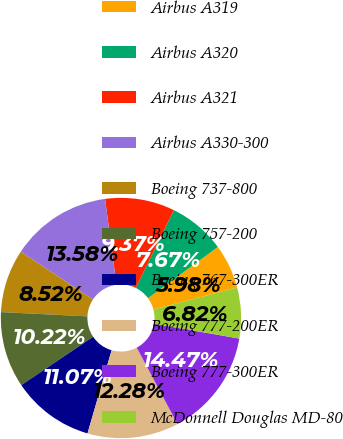<chart> <loc_0><loc_0><loc_500><loc_500><pie_chart><fcel>Airbus A319<fcel>Airbus A320<fcel>Airbus A321<fcel>Airbus A330-300<fcel>Boeing 737-800<fcel>Boeing 757-200<fcel>Boeing 767-300ER<fcel>Boeing 777-200ER<fcel>Boeing 777-300ER<fcel>McDonnell Douglas MD-80<nl><fcel>5.98%<fcel>7.67%<fcel>9.37%<fcel>13.58%<fcel>8.52%<fcel>10.22%<fcel>11.07%<fcel>12.28%<fcel>14.47%<fcel>6.82%<nl></chart> 